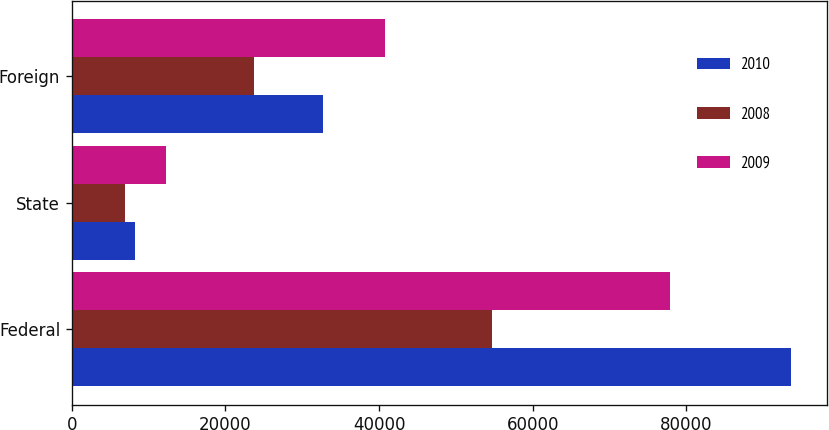Convert chart to OTSL. <chart><loc_0><loc_0><loc_500><loc_500><stacked_bar_chart><ecel><fcel>Federal<fcel>State<fcel>Foreign<nl><fcel>2010<fcel>93594<fcel>8185<fcel>32706<nl><fcel>2008<fcel>54636<fcel>6990<fcel>23720<nl><fcel>2009<fcel>77920<fcel>12309<fcel>40739<nl></chart> 